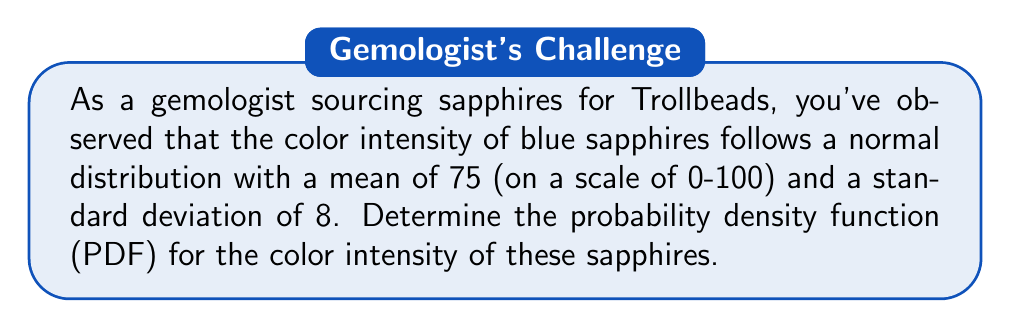Can you answer this question? To determine the probability density function (PDF) for the color intensity of blue sapphires, we need to use the formula for the normal distribution PDF:

$$f(x) = \frac{1}{\sigma\sqrt{2\pi}} e^{-\frac{(x-\mu)^2}{2\sigma^2}}$$

Where:
$f(x)$ is the probability density function
$x$ is the color intensity value
$\mu$ is the mean of the distribution
$\sigma$ is the standard deviation of the distribution
$e$ is Euler's number (approximately 2.71828)
$\pi$ is pi (approximately 3.14159)

Given:
$\mu = 75$ (mean color intensity)
$\sigma = 8$ (standard deviation of color intensity)

Step 1: Substitute the given values into the formula:

$$f(x) = \frac{1}{8\sqrt{2\pi}} e^{-\frac{(x-75)^2}{2(8)^2}}$$

Step 2: Simplify the expression:

$$f(x) = \frac{1}{8\sqrt{2\pi}} e^{-\frac{(x-75)^2}{128}}$$

This is the final form of the probability density function for the color intensity of blue sapphires based on the given parameters.
Answer: $$f(x) = \frac{1}{8\sqrt{2\pi}} e^{-\frac{(x-75)^2}{128}}$$ 